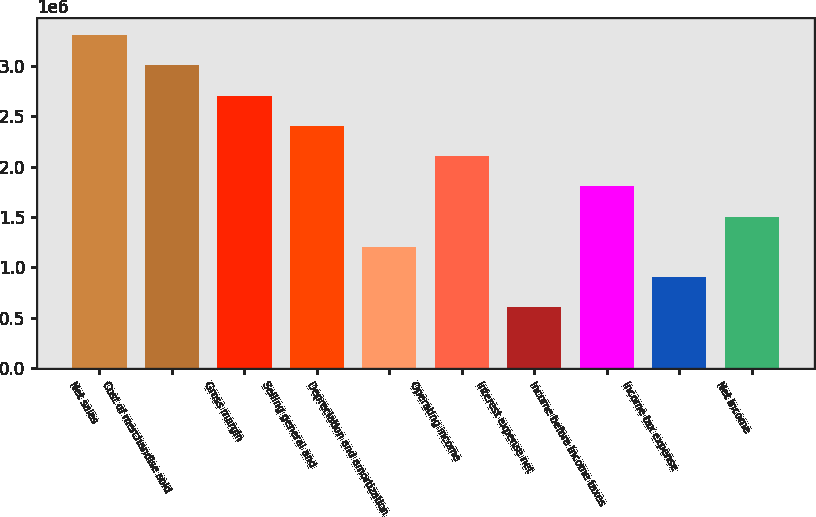Convert chart. <chart><loc_0><loc_0><loc_500><loc_500><bar_chart><fcel>Net sales<fcel>Cost of merchandise sold<fcel>Gross margin<fcel>Selling general and<fcel>Depreciation and amortization<fcel>Operating income<fcel>Interest expense net<fcel>Income before income taxes<fcel>Income tax expense<fcel>Net income<nl><fcel>3.30874e+06<fcel>3.00795e+06<fcel>2.70715e+06<fcel>2.40636e+06<fcel>1.20318e+06<fcel>2.10556e+06<fcel>601592<fcel>1.80477e+06<fcel>902386<fcel>1.50398e+06<nl></chart> 